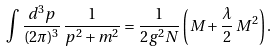<formula> <loc_0><loc_0><loc_500><loc_500>\int \frac { d ^ { 3 } p } { ( 2 \pi ) ^ { 3 } } \, \frac { 1 } { p ^ { 2 } + m ^ { 2 } } = \frac { 1 } { 2 g ^ { 2 } N } \left ( M + \frac { \lambda } { 2 } \, M ^ { 2 } \right ) .</formula> 